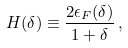Convert formula to latex. <formula><loc_0><loc_0><loc_500><loc_500>H ( \delta ) \equiv \frac { 2 \epsilon _ { F } ( \delta ) } { 1 + \delta } \, ,</formula> 